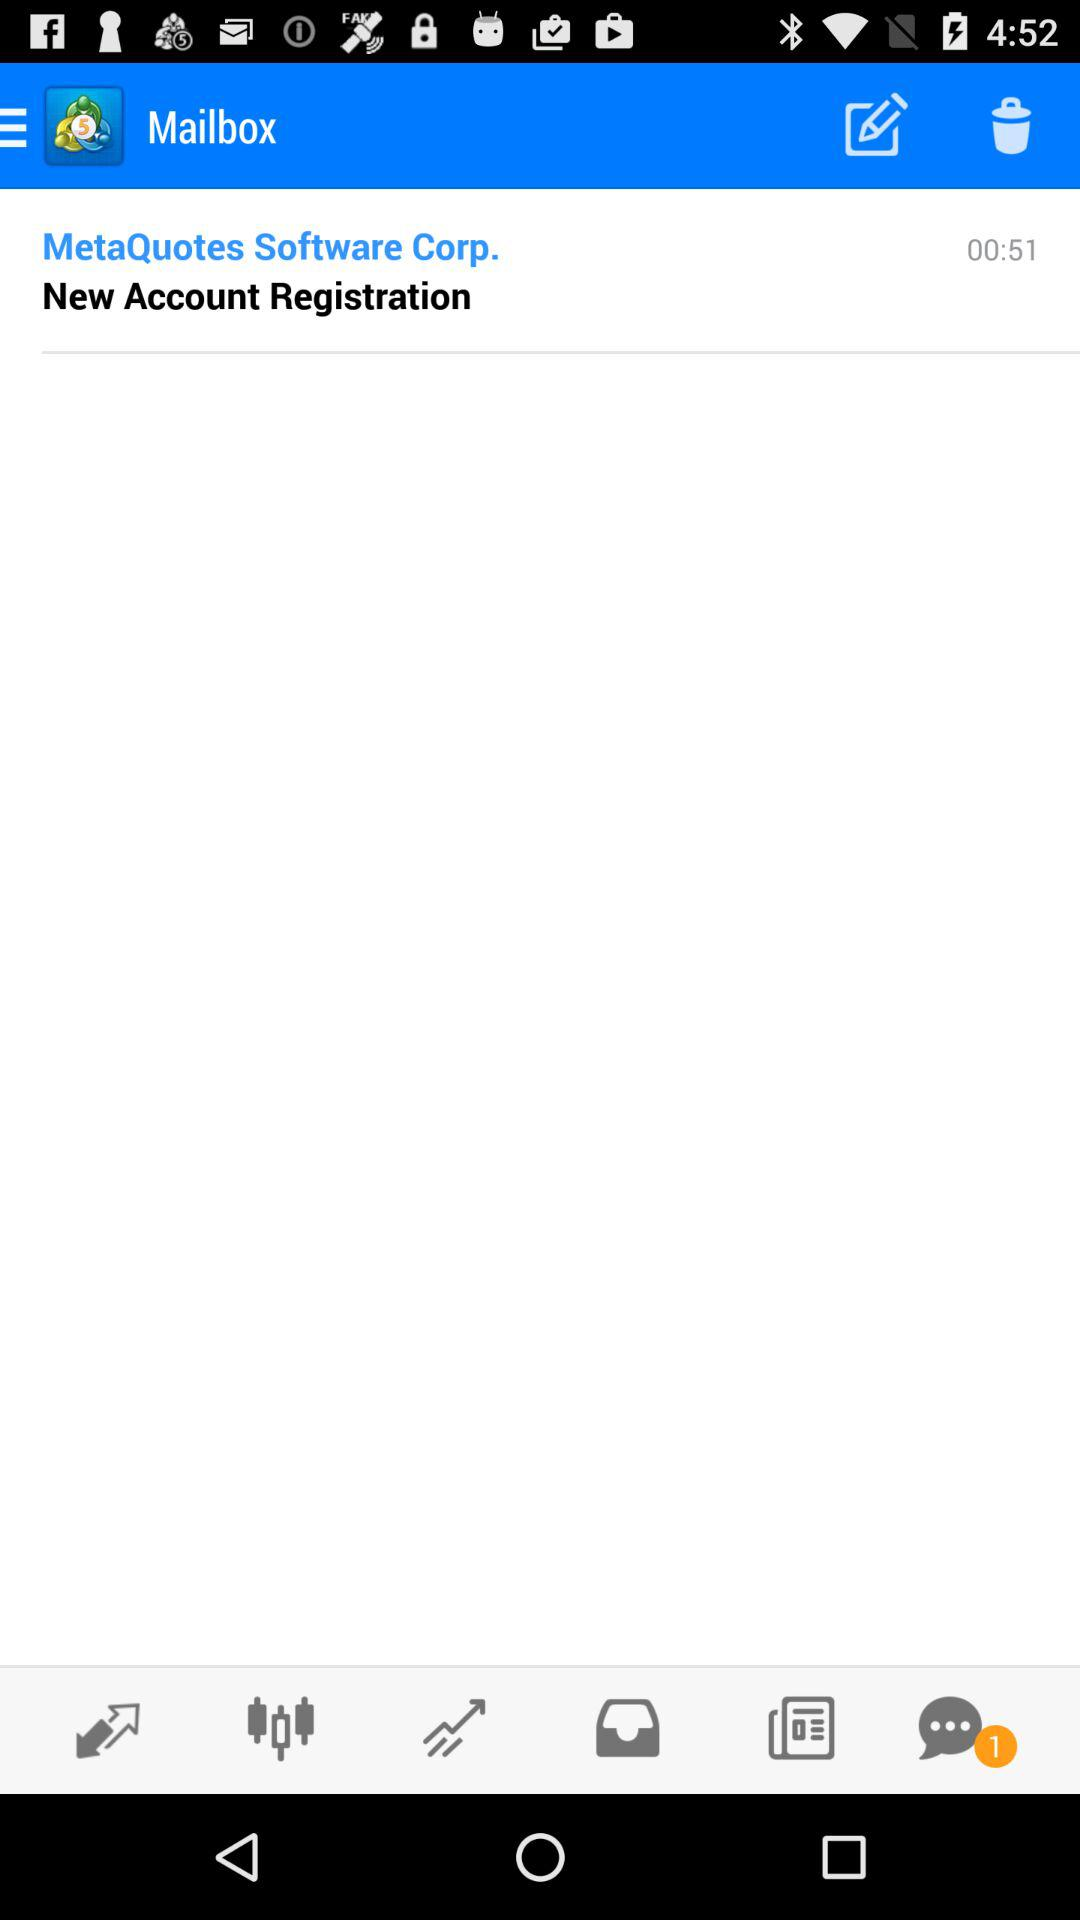What time did the email arrive from "MetaQuotes Software Corp."? The email arrived at 00:51. 